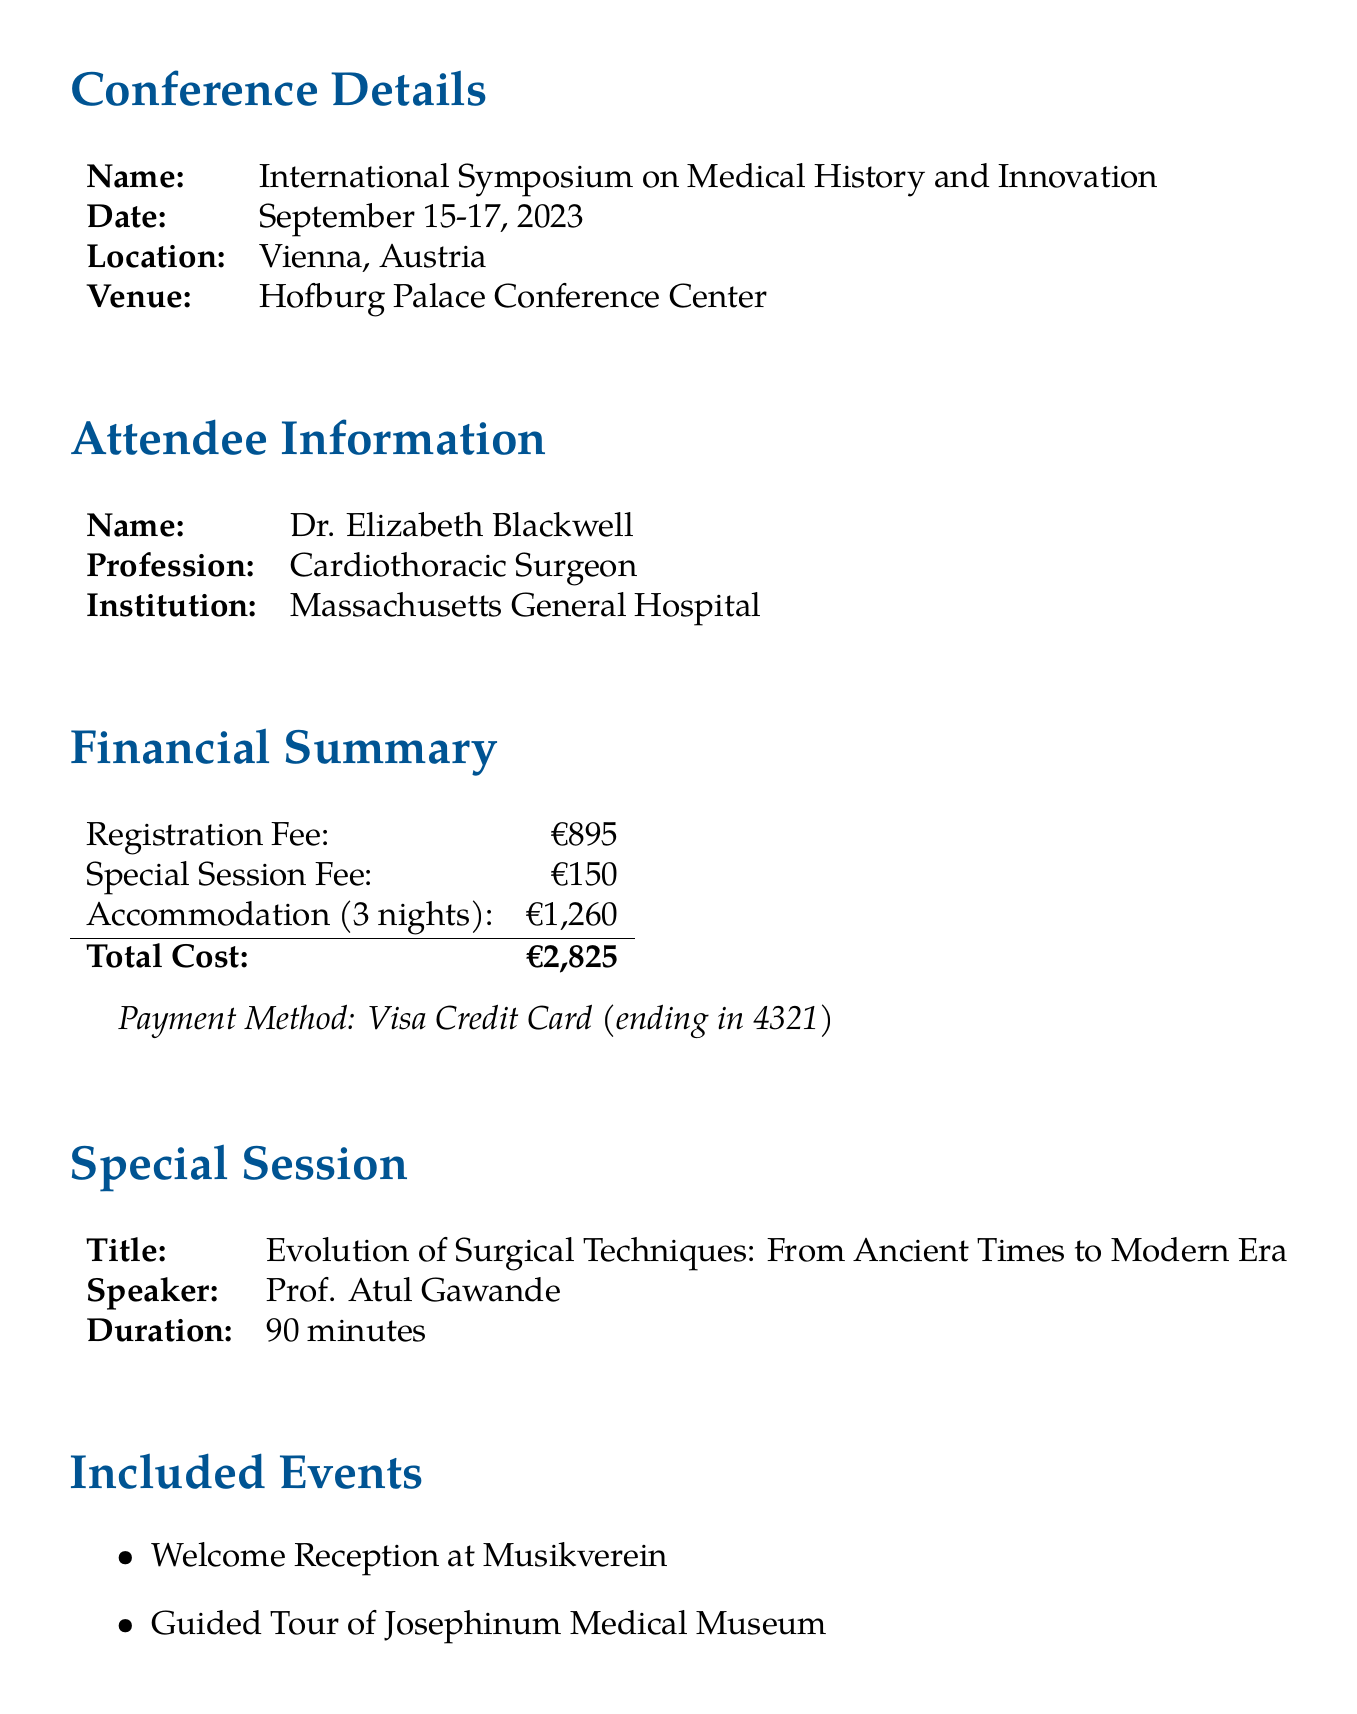What is the name of the conference? The name of the conference is stated clearly in the document as "International Symposium on Medical History and Innovation."
Answer: International Symposium on Medical History and Innovation Who is the speaker for the special session? The document specifies that the speaker for the special session is "Prof. Atul Gawande."
Answer: Prof. Atul Gawande What is the duration of the special session? The document indicates the duration of the special session is "90 minutes."
Answer: 90 minutes How much was the registration fee? The document provides the registration fee, which is €895.
Answer: €895 What institution does the attendee belong to? According to the document, the attendee belongs to "Massachusetts General Hospital."
Answer: Massachusetts General Hospital What additional fee is associated with attending the special session? The document mentions an additional fee of "€150" for the special session.
Answer: €150 How many CME credits were earned from the conference? The document states that the total CME credits earned from the conference were "18."
Answer: 18 What is the total cost incurred for the conference? The document sums up the total cost as €2825, which includes various fees.
Answer: €2825 What is the hotel name for accommodations? The document specifies the name of the hotel for accommodations as "Hotel Sacher Wien."
Answer: Hotel Sacher Wien 